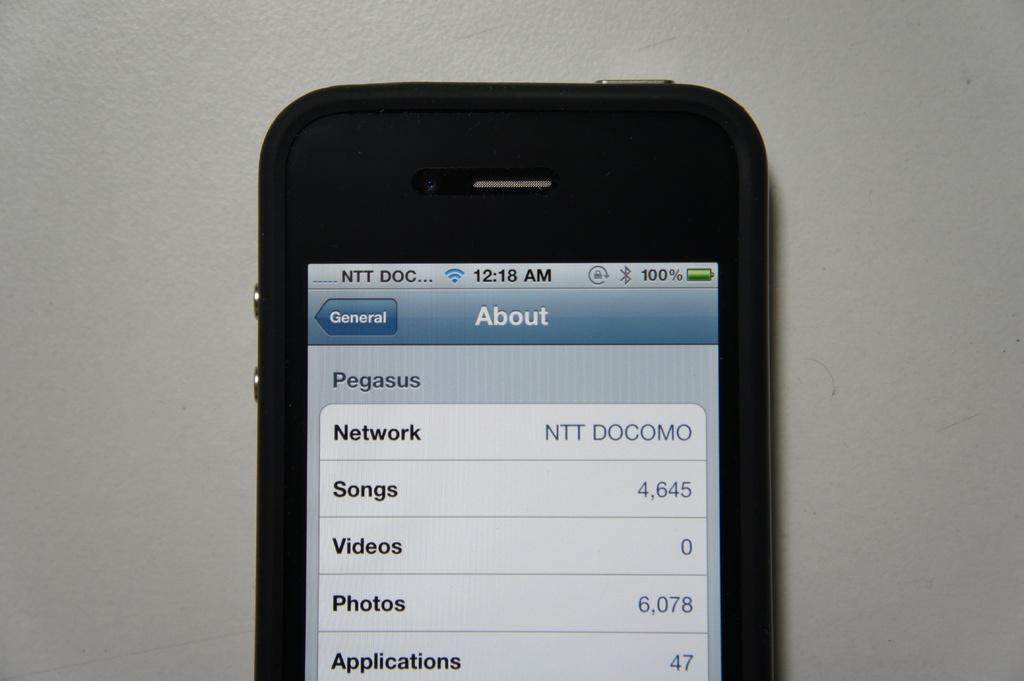What time is shown?
Your response must be concise. 12:18 am. 